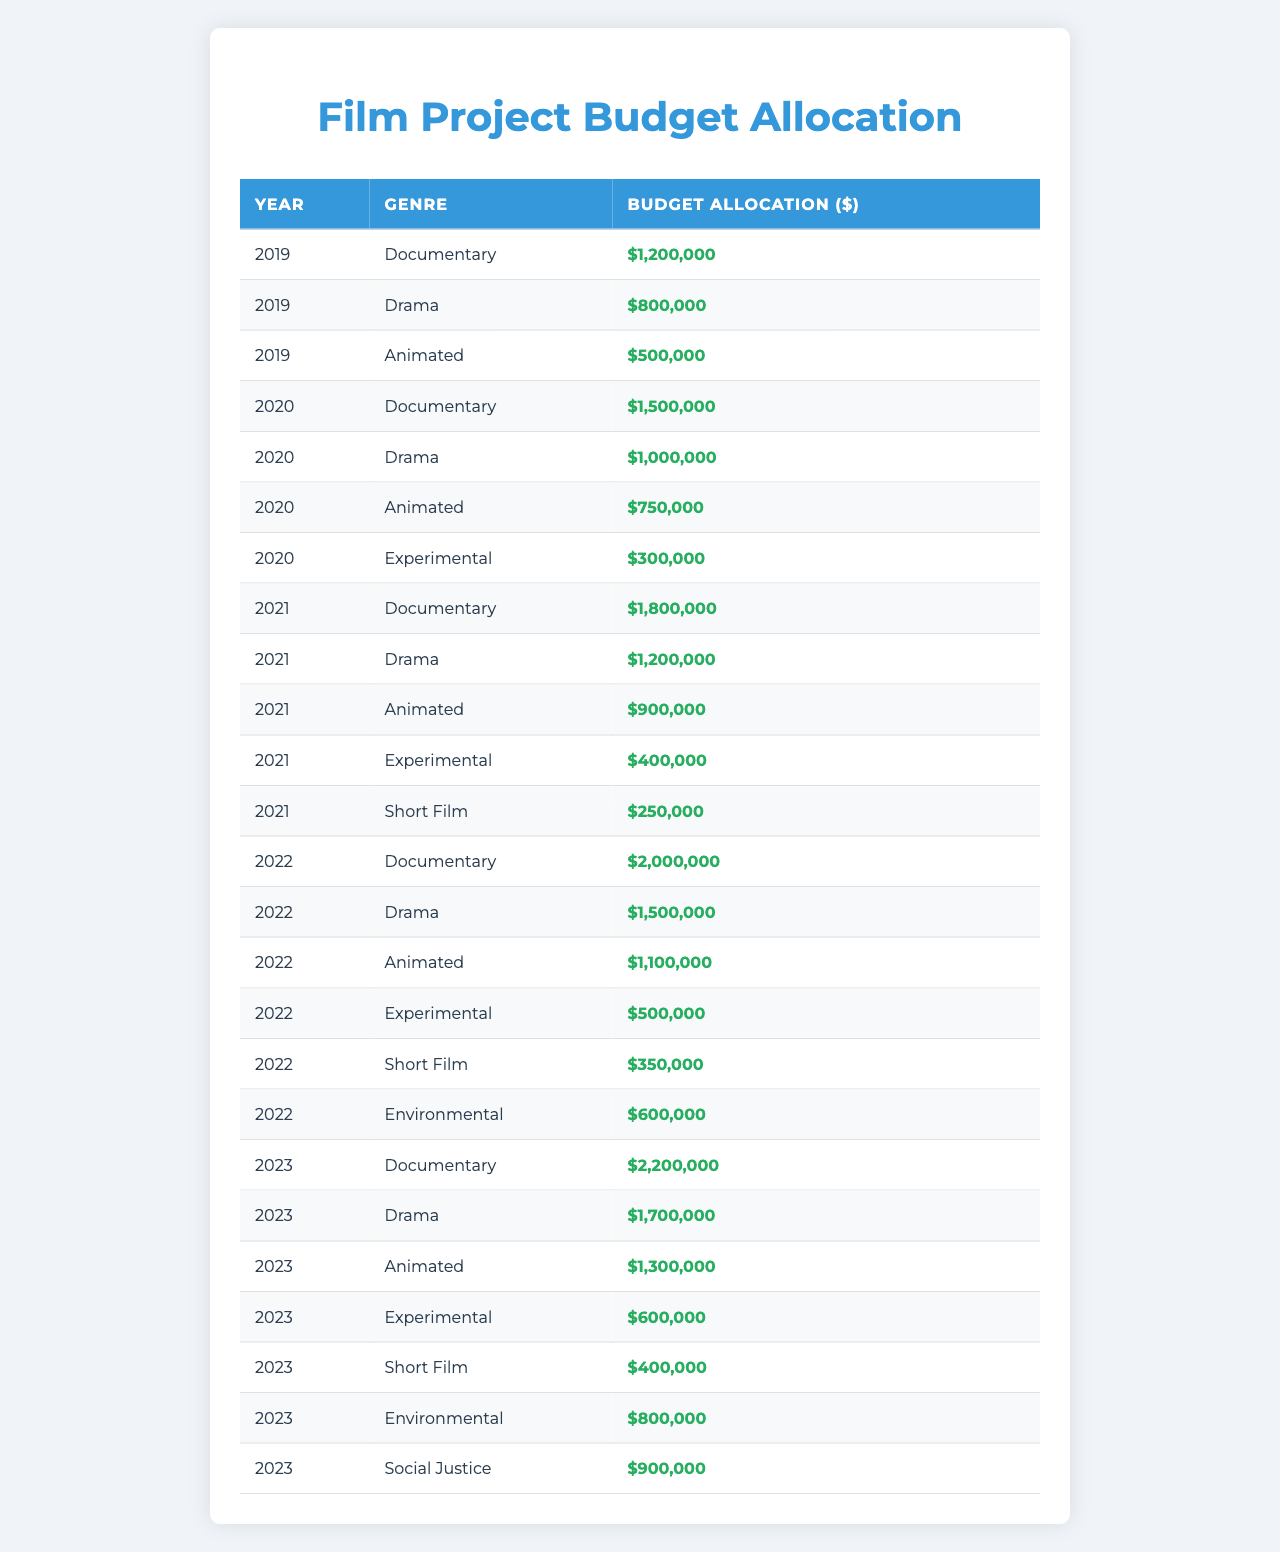What was the budget allocation for animated films in 2022? In the row for the year 2022 and the genre Animated, the budget allocation is listed as $1,100,000.
Answer: $1,100,000 Which genre received the highest budget in 2023? Looking at the 2023 data, the genre Documentary has the highest allocation at $2,200,000.
Answer: Documentary What is the total budget allocation for Drama films over the last 5 years? Summing the budget allocations for Drama from each year: 2019 ($800,000) + 2020 ($1,000,000) + 2021 ($1,200,000) + 2022 ($1,500,000) + 2023 ($1,700,000) = $6,200,000.
Answer: $6,200,000 Did the budget for Documentary films increase every year from 2019 to 2023? The budget allocations are: 2019 ($1,200,000), 2020 ($1,500,000), 2021 ($1,800,000), 2022 ($2,000,000), and 2023 ($2,200,000), which shows a consistent increase.
Answer: Yes What was the average budget allocation for Environmental films across the years they were supported? Environmental films have allocations for 2022 ($600,000) and 2023 ($800,000). The average is calculated as ($600,000 + $800,000) / 2 = $700,000.
Answer: $700,000 Looking at the total budget for Experimental films, which year had the highest allocation? The allocations for Experimental films are: 2020 ($300,000), 2021 ($400,000), and 2022 ($500,000), with 2023 having $600,000, making 2023 the highest year.
Answer: 2023 Calculate the total budget for all genres in 2021. The total budget allocation for 2021 is found by adding all allocations: Documentary ($1,800,000) + Drama ($1,200,000) + Animated ($900,000) + Experimental ($400,000) + Short Film ($250,000) = $4,550,000.
Answer: $4,550,000 Was the budget allocation for Short Films the same in all years? The allocations for Short Film are: 2021 ($250,000), 2022 ($350,000), and 2023 ($400,000), which shows that it is not the same across years.
Answer: No In which year did the Animated genre see its largest budget increase compared to the previous year? The Animated budgets are 2019 ($500,000), 2020 ($750,000), 2021 ($900,000), 2022 ($1,100,000), and 2023 ($1,300,000). The largest increase is from 2021 to 2022: $1,100,000 - $900,000 = $200,000.
Answer: 2022 How much more did the foundation allocate to Documentary films in 2023 than in 2019? The budget for Documentary in 2023 is $2,200,000 and for 2019 it was $1,200,000. Therefore, the difference is $2,200,000 - $1,200,000 = $1,000,000.
Answer: $1,000,000 